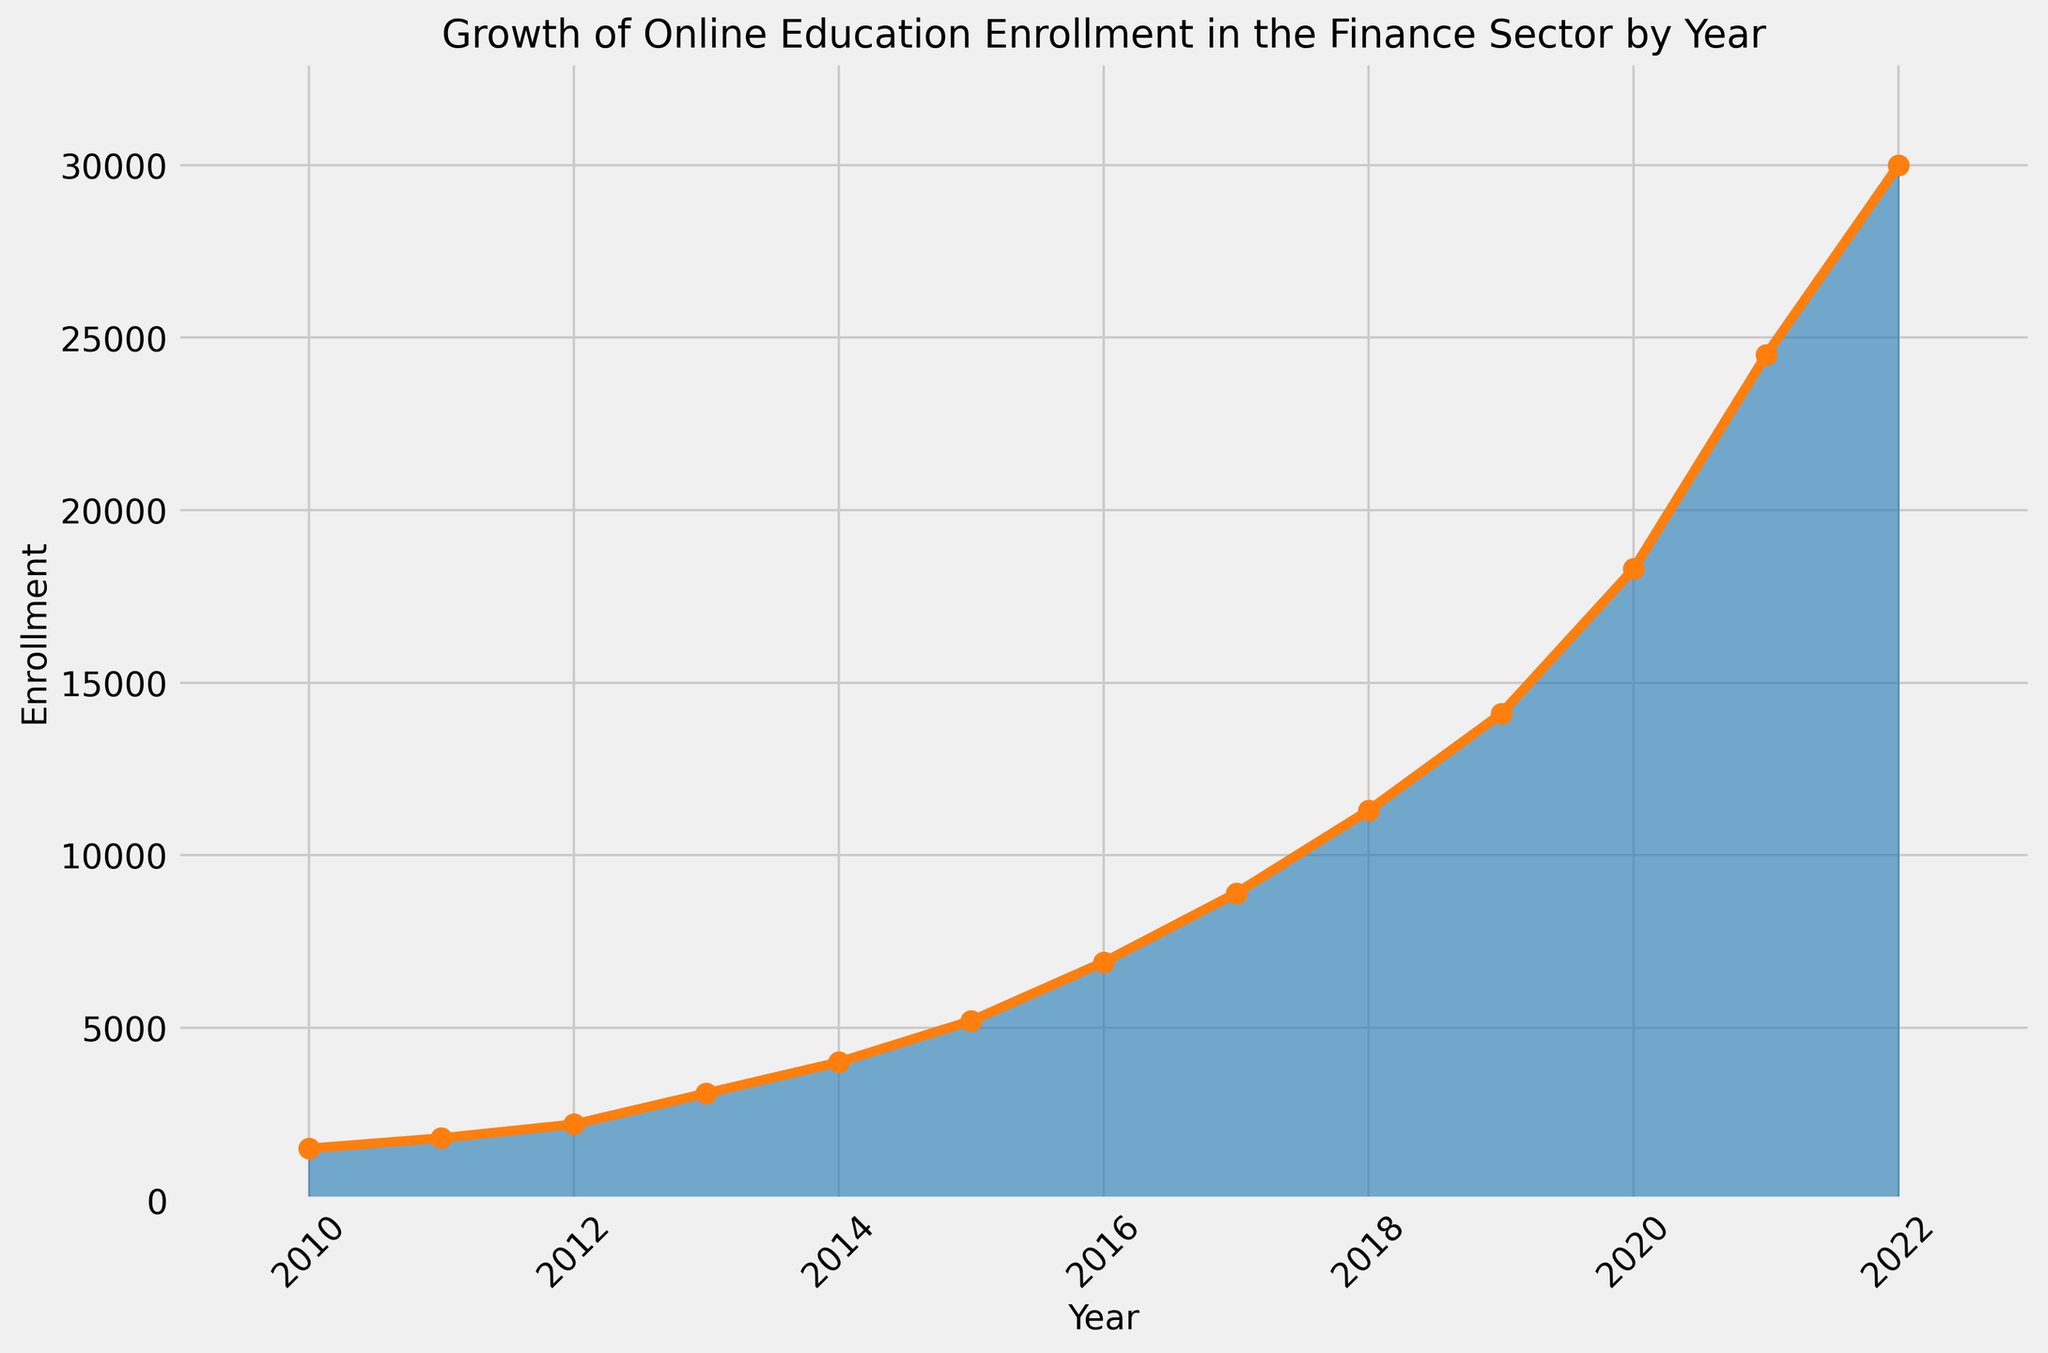What's the enrollment in 2015? Refer to the point on the y-axis corresponding to the year 2015. The y-value indicates the enrollment for that year.
Answer: 5200 What was the percentage increase in enrollment from 2019 to 2020? Calculate the difference in enrollment between 2020 and 2019, then divide by the 2019 enrollment and multiply by 100. (18300 - 14100) / 14100 * 100 = 29.79%.
Answer: 29.79% In which year did the enrollment first exceed 10,000? Locate the point where the y-value first surpasses 10,000 by moving from left to right along the x-axis (Year).
Answer: 2018 Compare the enrollment in 2011 and 2012. Which year had higher enrollment and by how much? Look at the points corresponding to 2011 and 2012 on the y-axis. 2012 had higher enrollment. Subtract the 2011 enrollment from the 2012 enrollment (2200 - 1800 = 400).
Answer: 2012 had a higher enrollment by 400 What is the average annual enrollment from 2010 to 2015? Sum the enrollments from 2010 to 2015 and then divide by the number of years. (1500 + 1800 + 2200 + 3100 + 4000 + 5200) / 6 = 2966.67.
Answer: 2966.67 How does the enrollment growth rate from 2016 to 2017 compare to that from 2017 to 2018? Calculate the growth rates: (2017 enrollment - 2016 enrollment) / 2016 enrollment = (8900 - 6900) / 6900 ≈ 0.29. (2018 enrollment - 2017 enrollment) / 2017 enrollment = (11300 - 8900) / 8900 ≈ 0.27. The growth rate from 2016 to 2017 was slightly higher.
Answer: 2016-2017 had a higher growth rate Which year saw the highest increase in enrollment compared to the previous year? Calculate the annual increases and find the maximum. The highest increase is from 2021 to 2022: 30000 - 24500 = 5500.
Answer: 2021 to 2022 What color is used to represent the area under the curve in the area chart? Observe the filled area under the line in the chart which is colored "#1f77b4". It appears as a shade of blue.
Answer: Blue What is the enrollment trend from 2012 to 2014? Look at the y-axis values for 2012, 2013, and 2014. The enrollment steadily increases (2200 to 3100 to 4000).
Answer: Increasing trend 